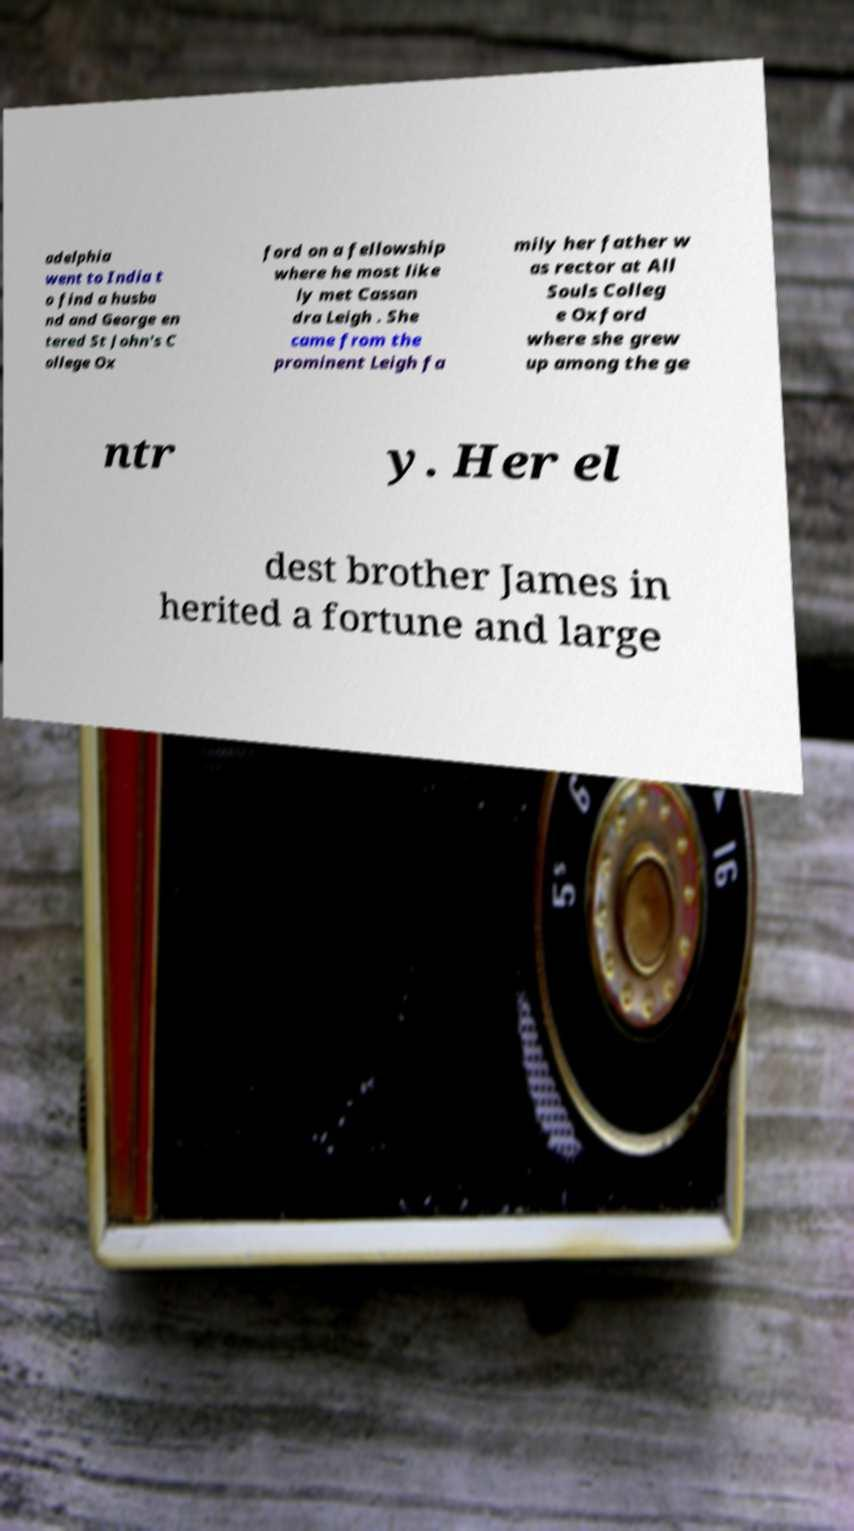Can you read and provide the text displayed in the image?This photo seems to have some interesting text. Can you extract and type it out for me? adelphia went to India t o find a husba nd and George en tered St John's C ollege Ox ford on a fellowship where he most like ly met Cassan dra Leigh . She came from the prominent Leigh fa mily her father w as rector at All Souls Colleg e Oxford where she grew up among the ge ntr y. Her el dest brother James in herited a fortune and large 